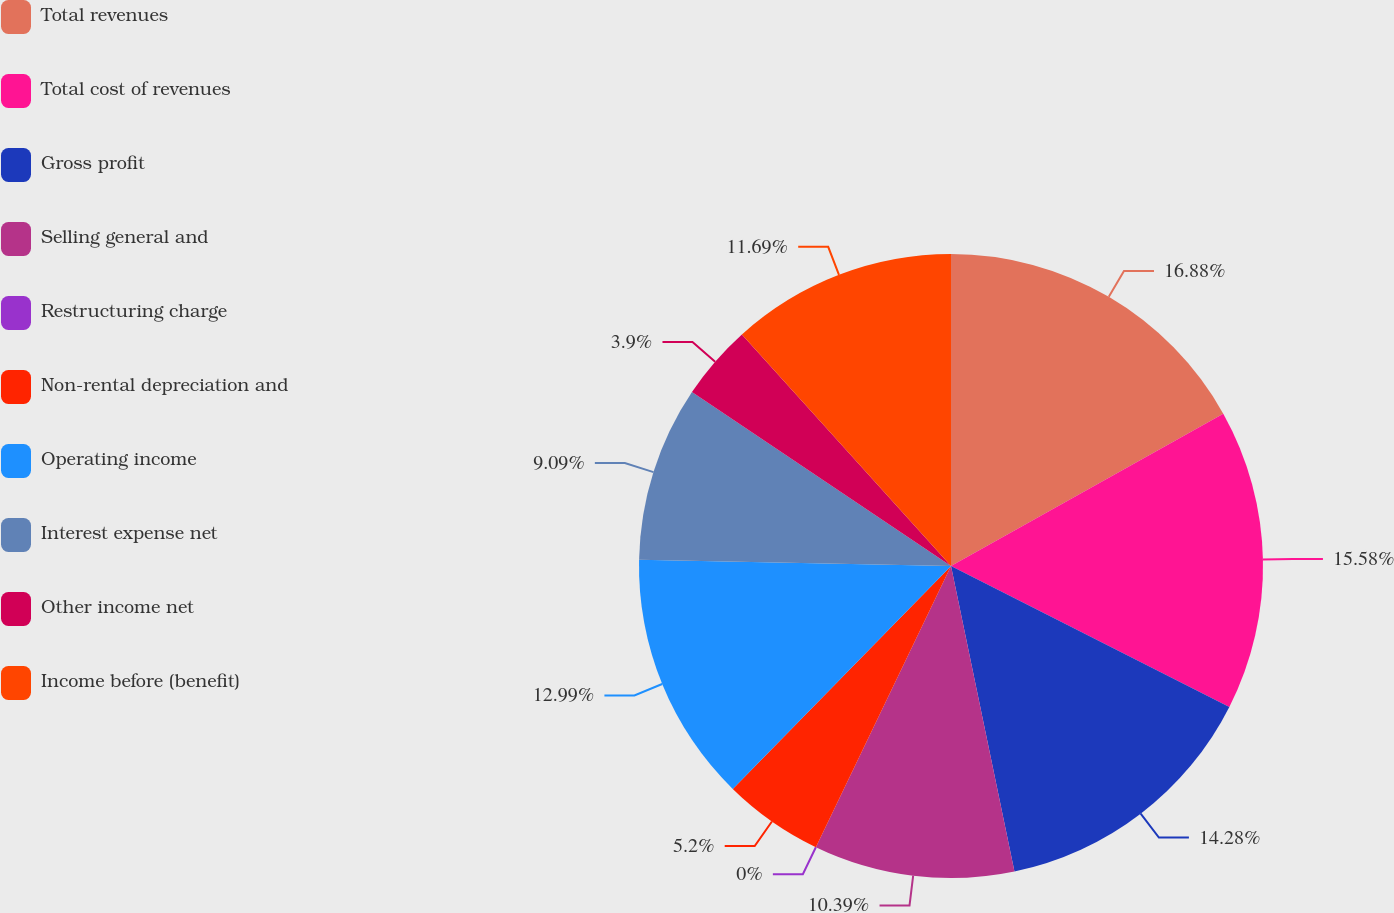Convert chart to OTSL. <chart><loc_0><loc_0><loc_500><loc_500><pie_chart><fcel>Total revenues<fcel>Total cost of revenues<fcel>Gross profit<fcel>Selling general and<fcel>Restructuring charge<fcel>Non-rental depreciation and<fcel>Operating income<fcel>Interest expense net<fcel>Other income net<fcel>Income before (benefit)<nl><fcel>16.88%<fcel>15.58%<fcel>14.28%<fcel>10.39%<fcel>0.0%<fcel>5.2%<fcel>12.99%<fcel>9.09%<fcel>3.9%<fcel>11.69%<nl></chart> 